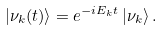<formula> <loc_0><loc_0><loc_500><loc_500>| \nu _ { k } ( t ) \rangle = e ^ { - i E _ { k } t } \, | \nu _ { k } \rangle \, .</formula> 